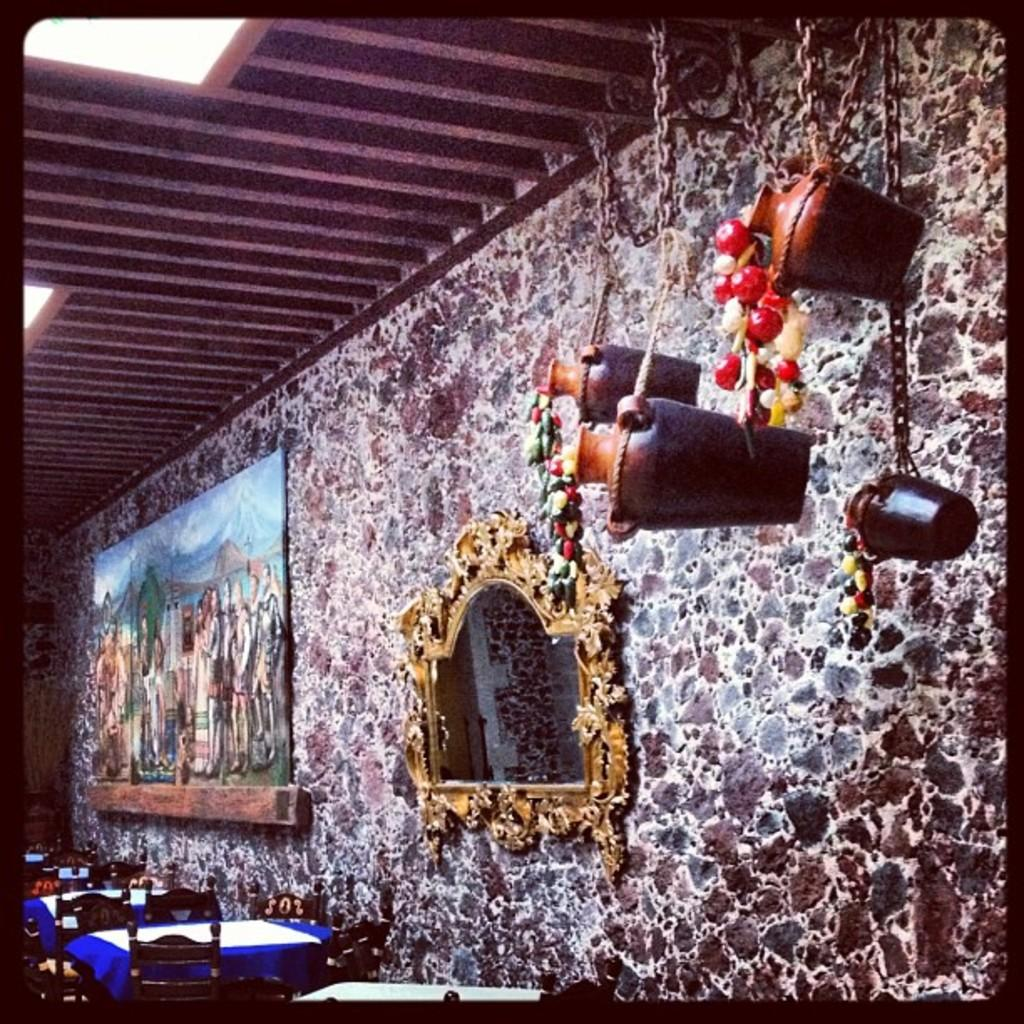What type of furniture is present in the image? There are tables and chairs in the image. Can you describe the background of the image? There is a mirror and a photo frame on the wall in the background of the image. What decorative item is hanged from the roof? There is a decorative item hanged to the roof in the image. What type of comb is used by the dinosaurs in the image? There are no dinosaurs present in the image, so there is no comb being used by them. What type of insurance is being advertised in the image? There is no insurance advertisement present in the image. 